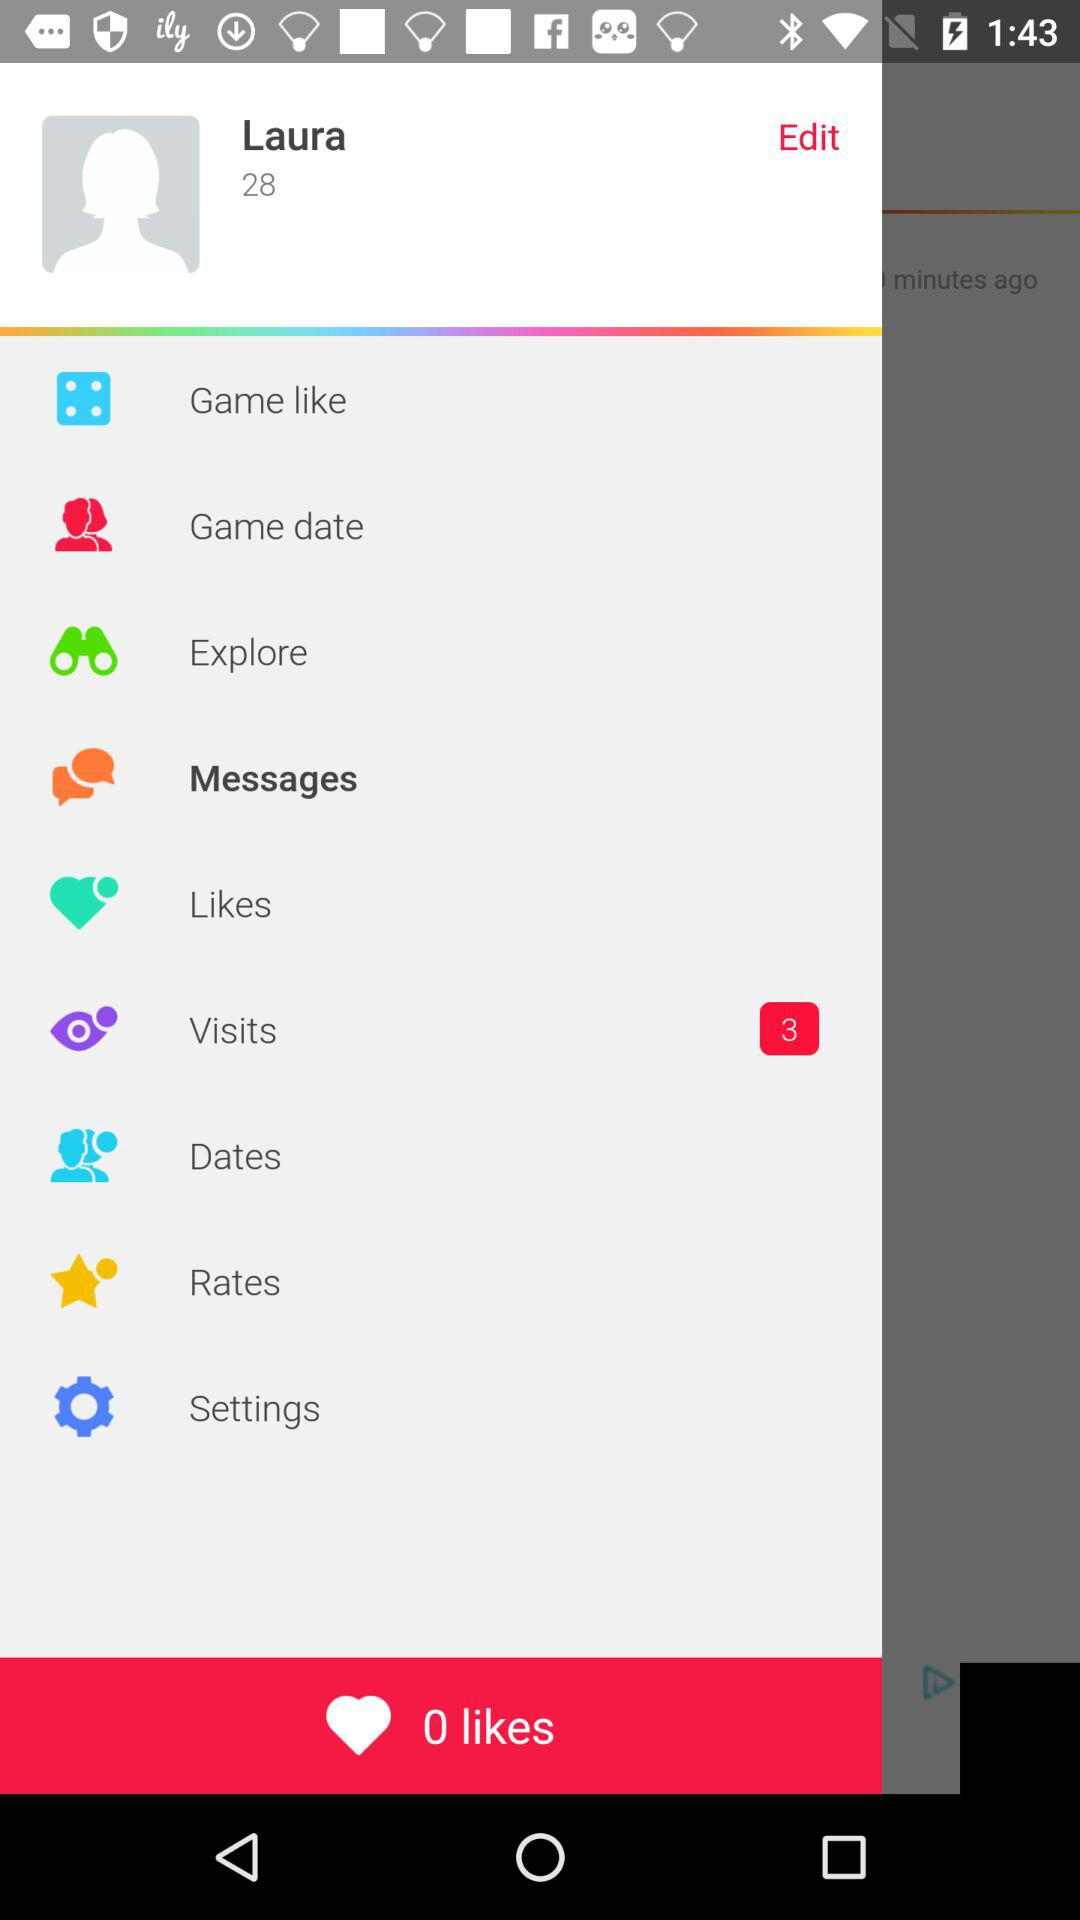How many likes are shown? The number of likes shown is 0. 